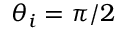Convert formula to latex. <formula><loc_0><loc_0><loc_500><loc_500>\theta _ { i } = \pi / 2</formula> 